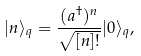Convert formula to latex. <formula><loc_0><loc_0><loc_500><loc_500>| n \rangle _ { q } = \frac { ( a ^ { \dagger } ) ^ { n } } { \sqrt { [ n ] ! } } | 0 \rangle _ { q } ,</formula> 